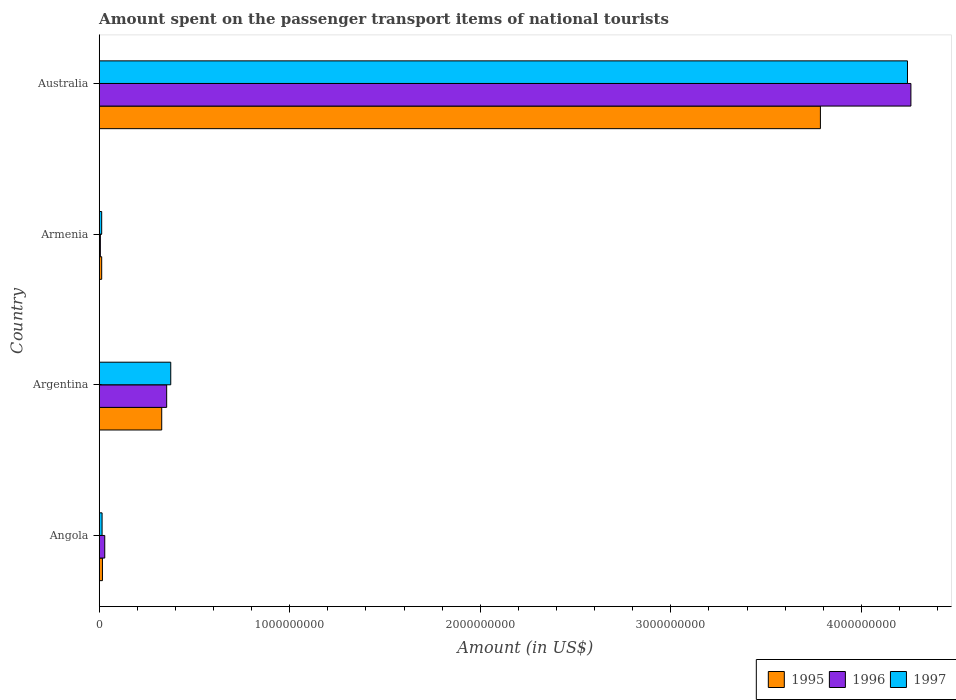How many different coloured bars are there?
Ensure brevity in your answer.  3. How many groups of bars are there?
Keep it short and to the point. 4. Are the number of bars per tick equal to the number of legend labels?
Ensure brevity in your answer.  Yes. Are the number of bars on each tick of the Y-axis equal?
Keep it short and to the point. Yes. How many bars are there on the 1st tick from the bottom?
Ensure brevity in your answer.  3. What is the label of the 1st group of bars from the top?
Give a very brief answer. Australia. What is the amount spent on the passenger transport items of national tourists in 1997 in Angola?
Your answer should be compact. 1.50e+07. Across all countries, what is the maximum amount spent on the passenger transport items of national tourists in 1997?
Ensure brevity in your answer.  4.24e+09. Across all countries, what is the minimum amount spent on the passenger transport items of national tourists in 1997?
Your response must be concise. 1.30e+07. In which country was the amount spent on the passenger transport items of national tourists in 1995 minimum?
Ensure brevity in your answer.  Armenia. What is the total amount spent on the passenger transport items of national tourists in 1996 in the graph?
Offer a very short reply. 4.65e+09. What is the difference between the amount spent on the passenger transport items of national tourists in 1997 in Argentina and that in Armenia?
Give a very brief answer. 3.62e+08. What is the difference between the amount spent on the passenger transport items of national tourists in 1995 in Armenia and the amount spent on the passenger transport items of national tourists in 1997 in Australia?
Offer a very short reply. -4.23e+09. What is the average amount spent on the passenger transport items of national tourists in 1996 per country?
Ensure brevity in your answer.  1.16e+09. What is the difference between the amount spent on the passenger transport items of national tourists in 1995 and amount spent on the passenger transport items of national tourists in 1997 in Australia?
Give a very brief answer. -4.57e+08. What is the ratio of the amount spent on the passenger transport items of national tourists in 1995 in Angola to that in Argentina?
Your response must be concise. 0.05. Is the difference between the amount spent on the passenger transport items of national tourists in 1995 in Angola and Australia greater than the difference between the amount spent on the passenger transport items of national tourists in 1997 in Angola and Australia?
Give a very brief answer. Yes. What is the difference between the highest and the second highest amount spent on the passenger transport items of national tourists in 1997?
Provide a short and direct response. 3.87e+09. What is the difference between the highest and the lowest amount spent on the passenger transport items of national tourists in 1996?
Ensure brevity in your answer.  4.25e+09. In how many countries, is the amount spent on the passenger transport items of national tourists in 1997 greater than the average amount spent on the passenger transport items of national tourists in 1997 taken over all countries?
Your answer should be compact. 1. What does the 2nd bar from the bottom in Argentina represents?
Make the answer very short. 1996. Is it the case that in every country, the sum of the amount spent on the passenger transport items of national tourists in 1997 and amount spent on the passenger transport items of national tourists in 1995 is greater than the amount spent on the passenger transport items of national tourists in 1996?
Ensure brevity in your answer.  Yes. How many countries are there in the graph?
Your response must be concise. 4. Does the graph contain any zero values?
Offer a very short reply. No. Does the graph contain grids?
Ensure brevity in your answer.  No. How many legend labels are there?
Make the answer very short. 3. How are the legend labels stacked?
Keep it short and to the point. Horizontal. What is the title of the graph?
Your answer should be very brief. Amount spent on the passenger transport items of national tourists. What is the label or title of the X-axis?
Give a very brief answer. Amount (in US$). What is the Amount (in US$) in 1995 in Angola?
Make the answer very short. 1.70e+07. What is the Amount (in US$) in 1996 in Angola?
Ensure brevity in your answer.  2.90e+07. What is the Amount (in US$) in 1997 in Angola?
Keep it short and to the point. 1.50e+07. What is the Amount (in US$) of 1995 in Argentina?
Make the answer very short. 3.28e+08. What is the Amount (in US$) in 1996 in Argentina?
Ensure brevity in your answer.  3.54e+08. What is the Amount (in US$) of 1997 in Argentina?
Make the answer very short. 3.75e+08. What is the Amount (in US$) in 1995 in Armenia?
Offer a terse response. 1.30e+07. What is the Amount (in US$) of 1997 in Armenia?
Make the answer very short. 1.30e+07. What is the Amount (in US$) of 1995 in Australia?
Offer a terse response. 3.78e+09. What is the Amount (in US$) of 1996 in Australia?
Your answer should be very brief. 4.26e+09. What is the Amount (in US$) in 1997 in Australia?
Give a very brief answer. 4.24e+09. Across all countries, what is the maximum Amount (in US$) in 1995?
Give a very brief answer. 3.78e+09. Across all countries, what is the maximum Amount (in US$) of 1996?
Your answer should be compact. 4.26e+09. Across all countries, what is the maximum Amount (in US$) of 1997?
Your answer should be very brief. 4.24e+09. Across all countries, what is the minimum Amount (in US$) in 1995?
Offer a terse response. 1.30e+07. Across all countries, what is the minimum Amount (in US$) in 1996?
Provide a succinct answer. 6.00e+06. Across all countries, what is the minimum Amount (in US$) in 1997?
Offer a very short reply. 1.30e+07. What is the total Amount (in US$) of 1995 in the graph?
Your answer should be compact. 4.14e+09. What is the total Amount (in US$) of 1996 in the graph?
Your answer should be very brief. 4.65e+09. What is the total Amount (in US$) of 1997 in the graph?
Provide a short and direct response. 4.65e+09. What is the difference between the Amount (in US$) in 1995 in Angola and that in Argentina?
Provide a short and direct response. -3.11e+08. What is the difference between the Amount (in US$) of 1996 in Angola and that in Argentina?
Keep it short and to the point. -3.25e+08. What is the difference between the Amount (in US$) in 1997 in Angola and that in Argentina?
Make the answer very short. -3.60e+08. What is the difference between the Amount (in US$) in 1996 in Angola and that in Armenia?
Offer a very short reply. 2.30e+07. What is the difference between the Amount (in US$) of 1997 in Angola and that in Armenia?
Your answer should be compact. 2.00e+06. What is the difference between the Amount (in US$) in 1995 in Angola and that in Australia?
Provide a short and direct response. -3.77e+09. What is the difference between the Amount (in US$) in 1996 in Angola and that in Australia?
Keep it short and to the point. -4.23e+09. What is the difference between the Amount (in US$) of 1997 in Angola and that in Australia?
Your answer should be compact. -4.23e+09. What is the difference between the Amount (in US$) in 1995 in Argentina and that in Armenia?
Provide a succinct answer. 3.15e+08. What is the difference between the Amount (in US$) of 1996 in Argentina and that in Armenia?
Give a very brief answer. 3.48e+08. What is the difference between the Amount (in US$) of 1997 in Argentina and that in Armenia?
Give a very brief answer. 3.62e+08. What is the difference between the Amount (in US$) in 1995 in Argentina and that in Australia?
Keep it short and to the point. -3.46e+09. What is the difference between the Amount (in US$) of 1996 in Argentina and that in Australia?
Your answer should be compact. -3.91e+09. What is the difference between the Amount (in US$) in 1997 in Argentina and that in Australia?
Offer a terse response. -3.87e+09. What is the difference between the Amount (in US$) in 1995 in Armenia and that in Australia?
Keep it short and to the point. -3.77e+09. What is the difference between the Amount (in US$) in 1996 in Armenia and that in Australia?
Your answer should be very brief. -4.25e+09. What is the difference between the Amount (in US$) of 1997 in Armenia and that in Australia?
Provide a short and direct response. -4.23e+09. What is the difference between the Amount (in US$) of 1995 in Angola and the Amount (in US$) of 1996 in Argentina?
Provide a short and direct response. -3.37e+08. What is the difference between the Amount (in US$) of 1995 in Angola and the Amount (in US$) of 1997 in Argentina?
Your answer should be very brief. -3.58e+08. What is the difference between the Amount (in US$) in 1996 in Angola and the Amount (in US$) in 1997 in Argentina?
Provide a succinct answer. -3.46e+08. What is the difference between the Amount (in US$) in 1995 in Angola and the Amount (in US$) in 1996 in Armenia?
Offer a very short reply. 1.10e+07. What is the difference between the Amount (in US$) in 1996 in Angola and the Amount (in US$) in 1997 in Armenia?
Offer a very short reply. 1.60e+07. What is the difference between the Amount (in US$) of 1995 in Angola and the Amount (in US$) of 1996 in Australia?
Provide a short and direct response. -4.24e+09. What is the difference between the Amount (in US$) of 1995 in Angola and the Amount (in US$) of 1997 in Australia?
Your answer should be compact. -4.22e+09. What is the difference between the Amount (in US$) of 1996 in Angola and the Amount (in US$) of 1997 in Australia?
Give a very brief answer. -4.21e+09. What is the difference between the Amount (in US$) in 1995 in Argentina and the Amount (in US$) in 1996 in Armenia?
Your answer should be very brief. 3.22e+08. What is the difference between the Amount (in US$) in 1995 in Argentina and the Amount (in US$) in 1997 in Armenia?
Ensure brevity in your answer.  3.15e+08. What is the difference between the Amount (in US$) in 1996 in Argentina and the Amount (in US$) in 1997 in Armenia?
Your response must be concise. 3.41e+08. What is the difference between the Amount (in US$) in 1995 in Argentina and the Amount (in US$) in 1996 in Australia?
Make the answer very short. -3.93e+09. What is the difference between the Amount (in US$) of 1995 in Argentina and the Amount (in US$) of 1997 in Australia?
Your answer should be compact. -3.91e+09. What is the difference between the Amount (in US$) of 1996 in Argentina and the Amount (in US$) of 1997 in Australia?
Provide a succinct answer. -3.89e+09. What is the difference between the Amount (in US$) in 1995 in Armenia and the Amount (in US$) in 1996 in Australia?
Keep it short and to the point. -4.25e+09. What is the difference between the Amount (in US$) in 1995 in Armenia and the Amount (in US$) in 1997 in Australia?
Give a very brief answer. -4.23e+09. What is the difference between the Amount (in US$) in 1996 in Armenia and the Amount (in US$) in 1997 in Australia?
Keep it short and to the point. -4.24e+09. What is the average Amount (in US$) of 1995 per country?
Your answer should be very brief. 1.04e+09. What is the average Amount (in US$) of 1996 per country?
Provide a succinct answer. 1.16e+09. What is the average Amount (in US$) in 1997 per country?
Provide a short and direct response. 1.16e+09. What is the difference between the Amount (in US$) in 1995 and Amount (in US$) in 1996 in Angola?
Ensure brevity in your answer.  -1.20e+07. What is the difference between the Amount (in US$) in 1995 and Amount (in US$) in 1997 in Angola?
Offer a terse response. 2.00e+06. What is the difference between the Amount (in US$) in 1996 and Amount (in US$) in 1997 in Angola?
Keep it short and to the point. 1.40e+07. What is the difference between the Amount (in US$) of 1995 and Amount (in US$) of 1996 in Argentina?
Give a very brief answer. -2.60e+07. What is the difference between the Amount (in US$) of 1995 and Amount (in US$) of 1997 in Argentina?
Ensure brevity in your answer.  -4.74e+07. What is the difference between the Amount (in US$) in 1996 and Amount (in US$) in 1997 in Argentina?
Give a very brief answer. -2.14e+07. What is the difference between the Amount (in US$) of 1996 and Amount (in US$) of 1997 in Armenia?
Your answer should be compact. -7.00e+06. What is the difference between the Amount (in US$) of 1995 and Amount (in US$) of 1996 in Australia?
Offer a terse response. -4.75e+08. What is the difference between the Amount (in US$) in 1995 and Amount (in US$) in 1997 in Australia?
Keep it short and to the point. -4.57e+08. What is the difference between the Amount (in US$) of 1996 and Amount (in US$) of 1997 in Australia?
Keep it short and to the point. 1.80e+07. What is the ratio of the Amount (in US$) in 1995 in Angola to that in Argentina?
Your answer should be compact. 0.05. What is the ratio of the Amount (in US$) of 1996 in Angola to that in Argentina?
Offer a terse response. 0.08. What is the ratio of the Amount (in US$) in 1995 in Angola to that in Armenia?
Ensure brevity in your answer.  1.31. What is the ratio of the Amount (in US$) of 1996 in Angola to that in Armenia?
Your answer should be very brief. 4.83. What is the ratio of the Amount (in US$) in 1997 in Angola to that in Armenia?
Provide a short and direct response. 1.15. What is the ratio of the Amount (in US$) in 1995 in Angola to that in Australia?
Your answer should be very brief. 0. What is the ratio of the Amount (in US$) of 1996 in Angola to that in Australia?
Make the answer very short. 0.01. What is the ratio of the Amount (in US$) in 1997 in Angola to that in Australia?
Give a very brief answer. 0. What is the ratio of the Amount (in US$) of 1995 in Argentina to that in Armenia?
Your answer should be compact. 25.23. What is the ratio of the Amount (in US$) in 1996 in Argentina to that in Armenia?
Your answer should be compact. 59. What is the ratio of the Amount (in US$) of 1997 in Argentina to that in Armenia?
Keep it short and to the point. 28.88. What is the ratio of the Amount (in US$) of 1995 in Argentina to that in Australia?
Offer a very short reply. 0.09. What is the ratio of the Amount (in US$) of 1996 in Argentina to that in Australia?
Offer a terse response. 0.08. What is the ratio of the Amount (in US$) of 1997 in Argentina to that in Australia?
Your answer should be compact. 0.09. What is the ratio of the Amount (in US$) in 1995 in Armenia to that in Australia?
Provide a succinct answer. 0. What is the ratio of the Amount (in US$) of 1996 in Armenia to that in Australia?
Provide a succinct answer. 0. What is the ratio of the Amount (in US$) of 1997 in Armenia to that in Australia?
Your answer should be compact. 0. What is the difference between the highest and the second highest Amount (in US$) in 1995?
Ensure brevity in your answer.  3.46e+09. What is the difference between the highest and the second highest Amount (in US$) of 1996?
Keep it short and to the point. 3.91e+09. What is the difference between the highest and the second highest Amount (in US$) in 1997?
Give a very brief answer. 3.87e+09. What is the difference between the highest and the lowest Amount (in US$) in 1995?
Ensure brevity in your answer.  3.77e+09. What is the difference between the highest and the lowest Amount (in US$) in 1996?
Your response must be concise. 4.25e+09. What is the difference between the highest and the lowest Amount (in US$) of 1997?
Ensure brevity in your answer.  4.23e+09. 